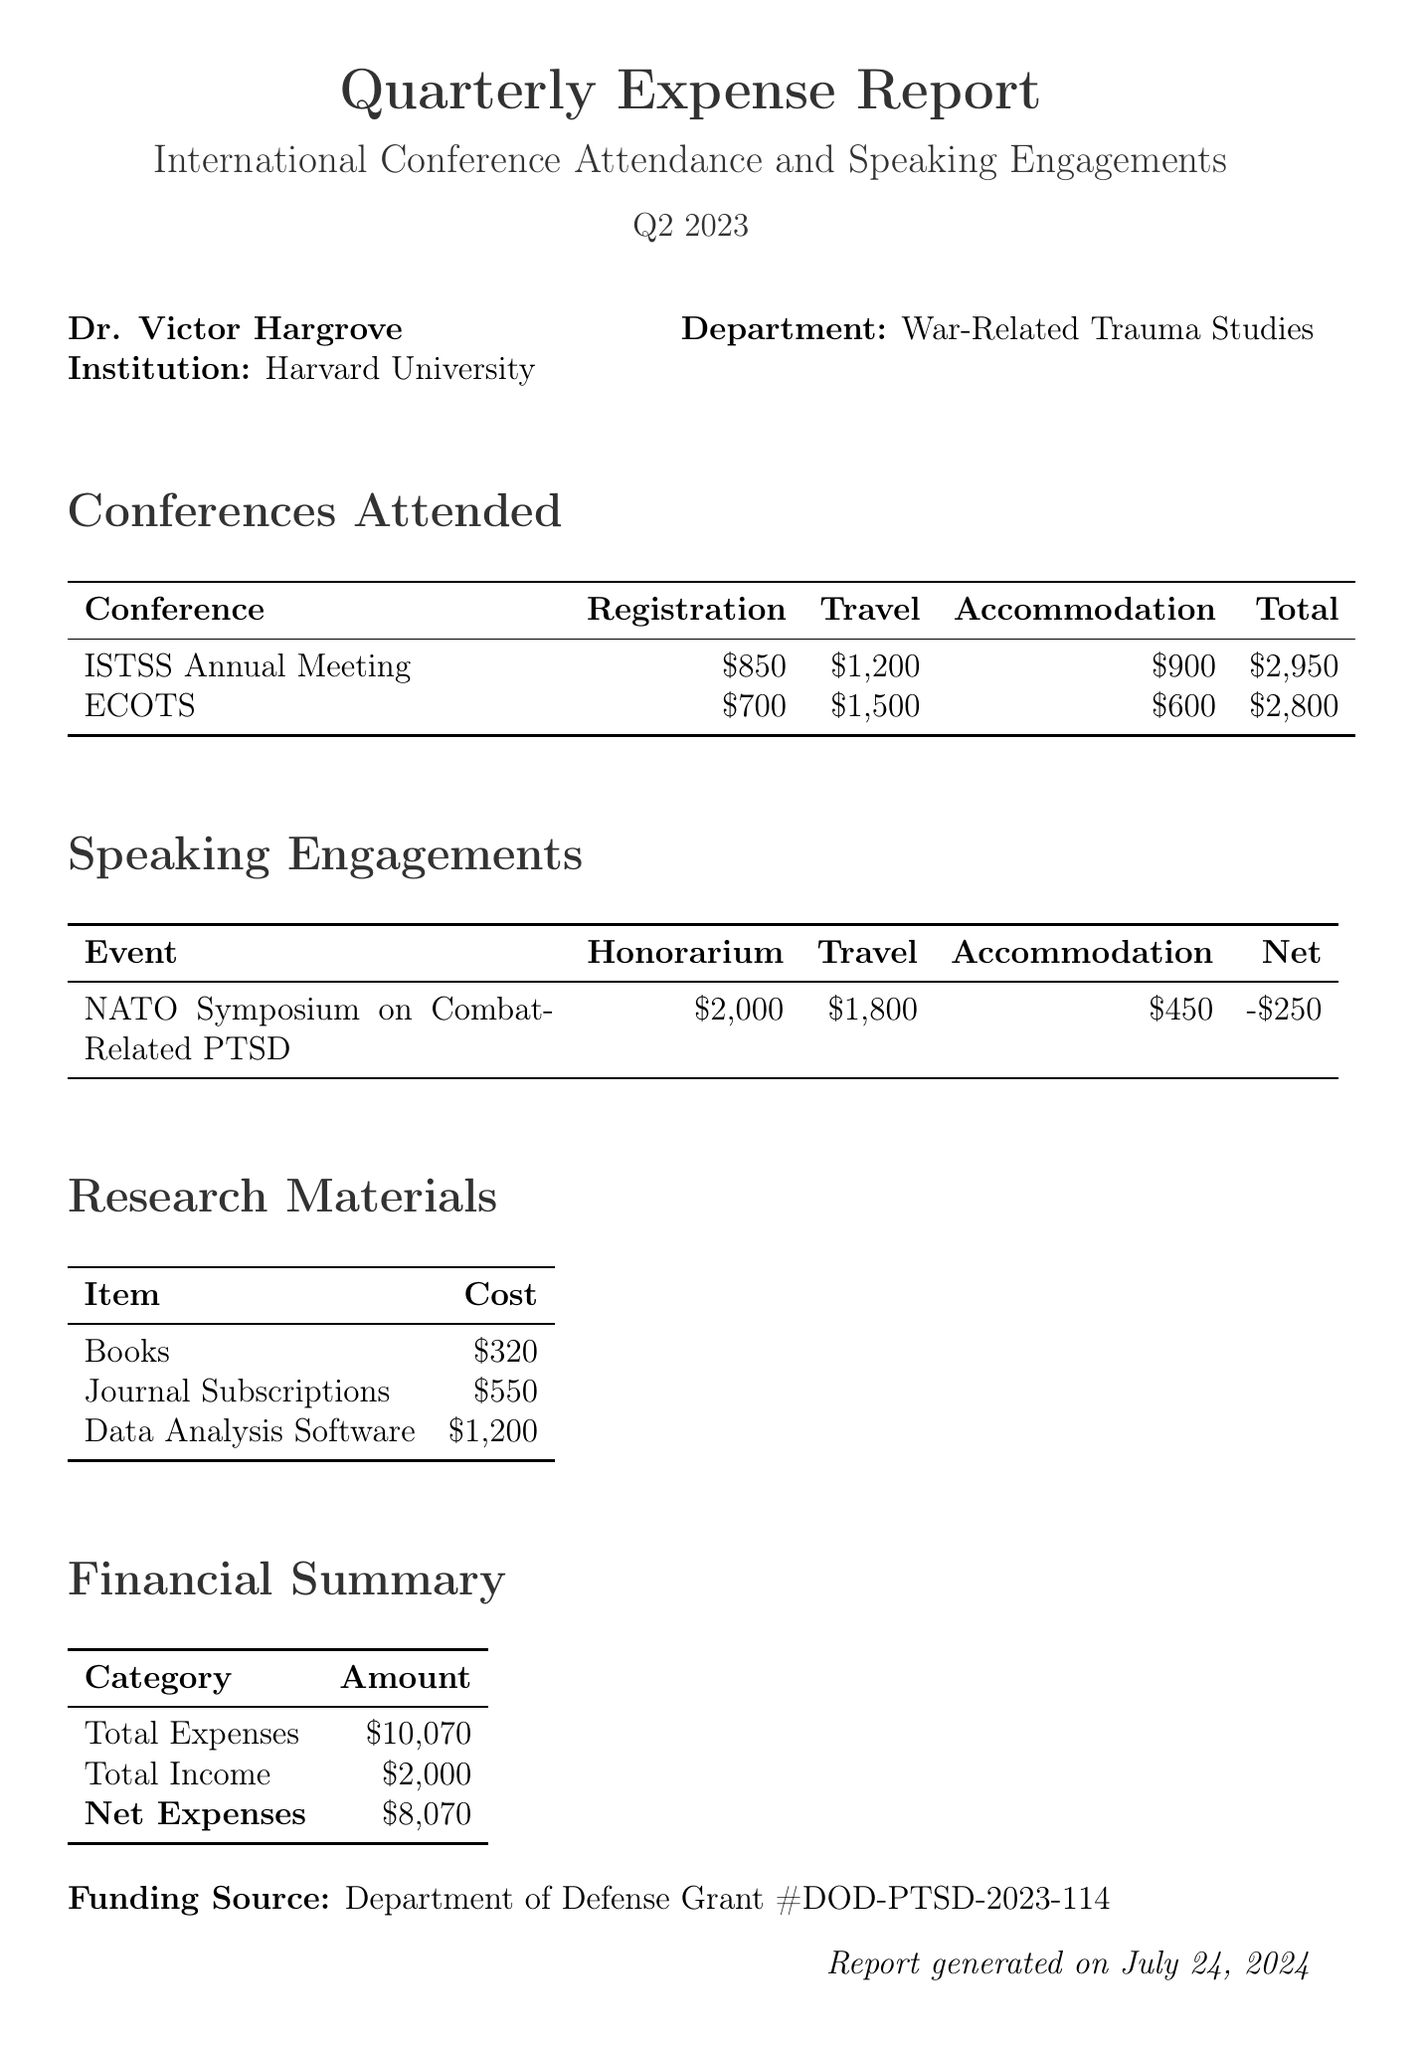What is the title of the report? The title of the report is explicitly stated at the beginning of the document as "Quarterly Expense Report for International Conference Attendance and Speaking Engagements".
Answer: Quarterly Expense Report for International Conference Attendance and Speaking Engagements Who is the author? The author's name is provided in the report header, identifying Dr. Victor Hargrove as the author.
Answer: Dr. Victor Hargrove What were the total travel expenses for the ISTSS Annual Meeting? Total travel expenses for the ISTSS Annual Meeting are listed in the conference details, amounting to $1200.
Answer: $1200 What is the honorarium for the NATO Symposium? The honorarium is detailed in the speaking engagements section, which specifies it as $2000.
Answer: $2000 What is the total amount spent on research materials? To find this, we sum up the costs listed under research materials: $320 + $550 + $1200 equals $2070.
Answer: $2070 What is the net expense amount reported? The net expenses are provided in the financial summary, which states the net expenses as $8070.
Answer: $8070 What is the location of the European Conference on Traumatic Stress? The document states that the European Conference on Traumatic Stress (ECOTS) is held in Rotterdam, Netherlands.
Answer: Rotterdam, Netherlands How many conferences were attended in Q2 2023? Two conferences are listed in the "Conferences Attended" section, indicating a total of two attended conferences.
Answer: 2 Who funded the reported expenses? The funding source for the expenses is specified at the end of the document as the Department of Defense Grant.
Answer: Department of Defense Grant #DOD-PTSD-2023-114 